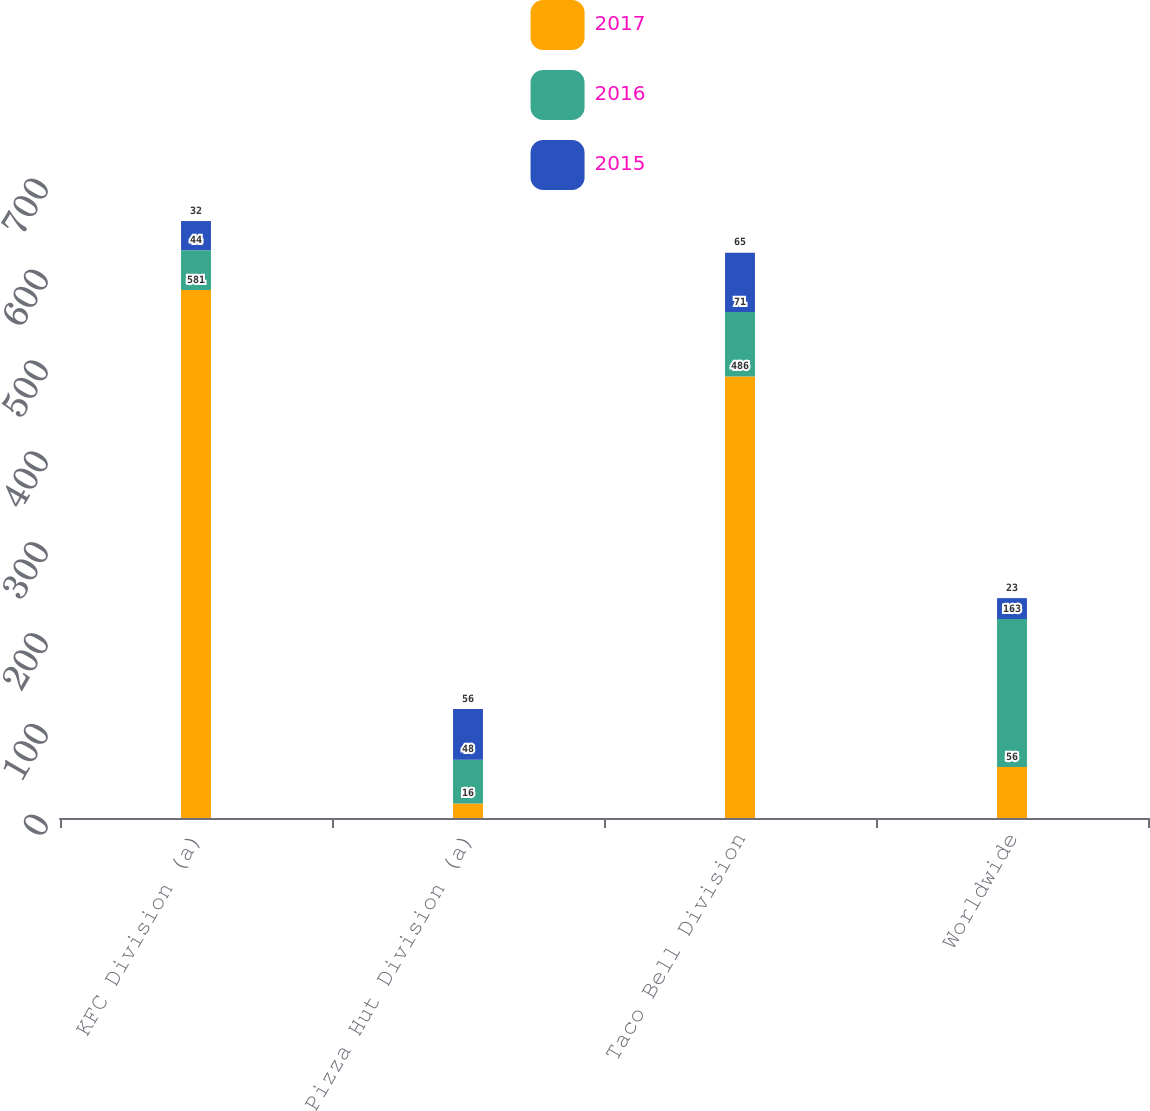<chart> <loc_0><loc_0><loc_500><loc_500><stacked_bar_chart><ecel><fcel>KFC Division (a)<fcel>Pizza Hut Division (a)<fcel>Taco Bell Division<fcel>Worldwide<nl><fcel>2017<fcel>581<fcel>16<fcel>486<fcel>56<nl><fcel>2016<fcel>44<fcel>48<fcel>71<fcel>163<nl><fcel>2015<fcel>32<fcel>56<fcel>65<fcel>23<nl></chart> 